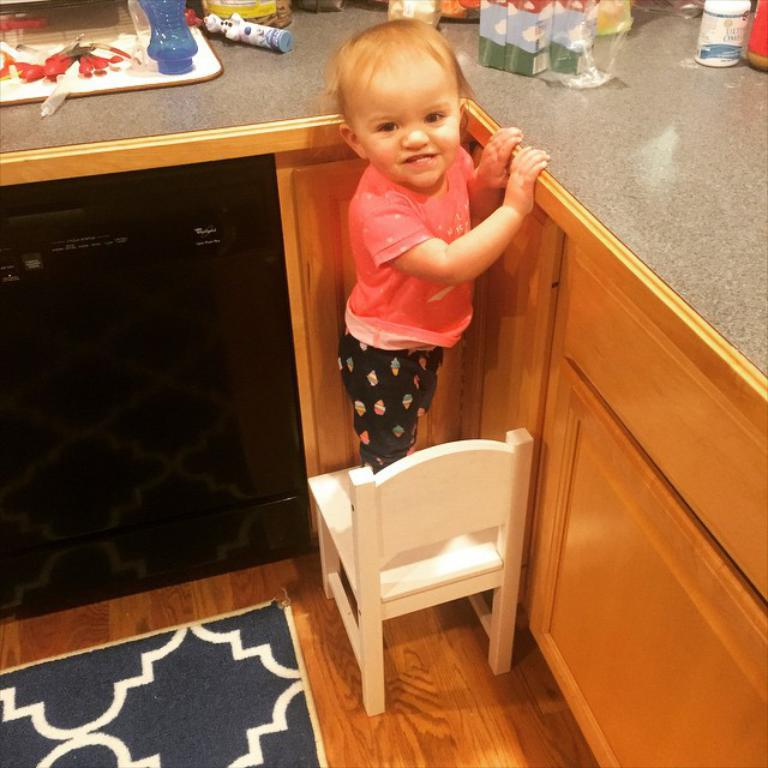What is the child doing in the image? The child is standing on a chair in the image. What is on the floor beneath the child? There is a mat on the floor. What other objects are on the floor? There is a tray, a bottle, and boxes on the floor. What type of mint can be seen growing on the chair in the image? There is no mint present in the image; the child is standing on a chair. 